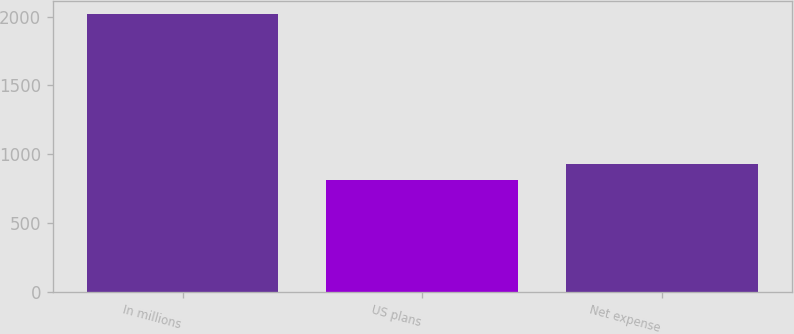<chart> <loc_0><loc_0><loc_500><loc_500><bar_chart><fcel>In millions<fcel>US plans<fcel>Net expense<nl><fcel>2016<fcel>809<fcel>929.7<nl></chart> 